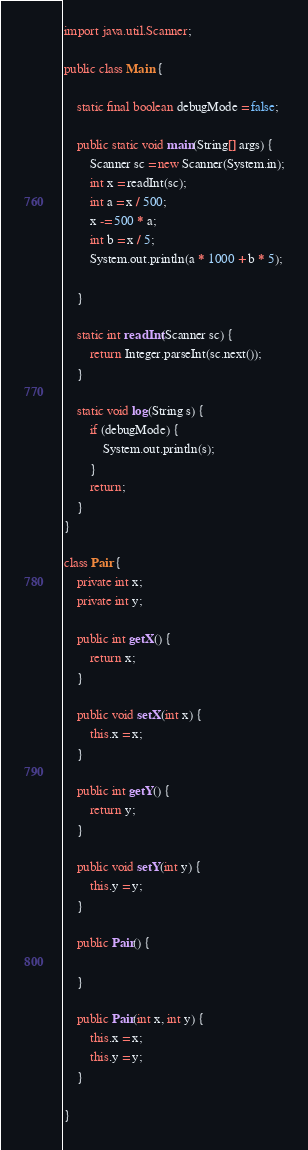Convert code to text. <code><loc_0><loc_0><loc_500><loc_500><_Java_>import java.util.Scanner;

public class Main {

	static final boolean debugMode = false;

	public static void main(String[] args) {
		Scanner sc = new Scanner(System.in);
		int x = readInt(sc);
		int a = x / 500;
		x -= 500 * a;
		int b = x / 5;
		System.out.println(a * 1000 + b * 5);

	}

	static int readInt(Scanner sc) {
		return Integer.parseInt(sc.next());
	}

	static void log(String s) {
		if (debugMode) {
			System.out.println(s);
		}
		return;
	}
}

class Pair {
	private int x;
	private int y;

	public int getX() {
		return x;
	}

	public void setX(int x) {
		this.x = x;
	}

	public int getY() {
		return y;
	}

	public void setY(int y) {
		this.y = y;
	}

	public Pair() {

	}

	public Pair(int x, int y) {
		this.x = x;
		this.y = y;
	}

}</code> 